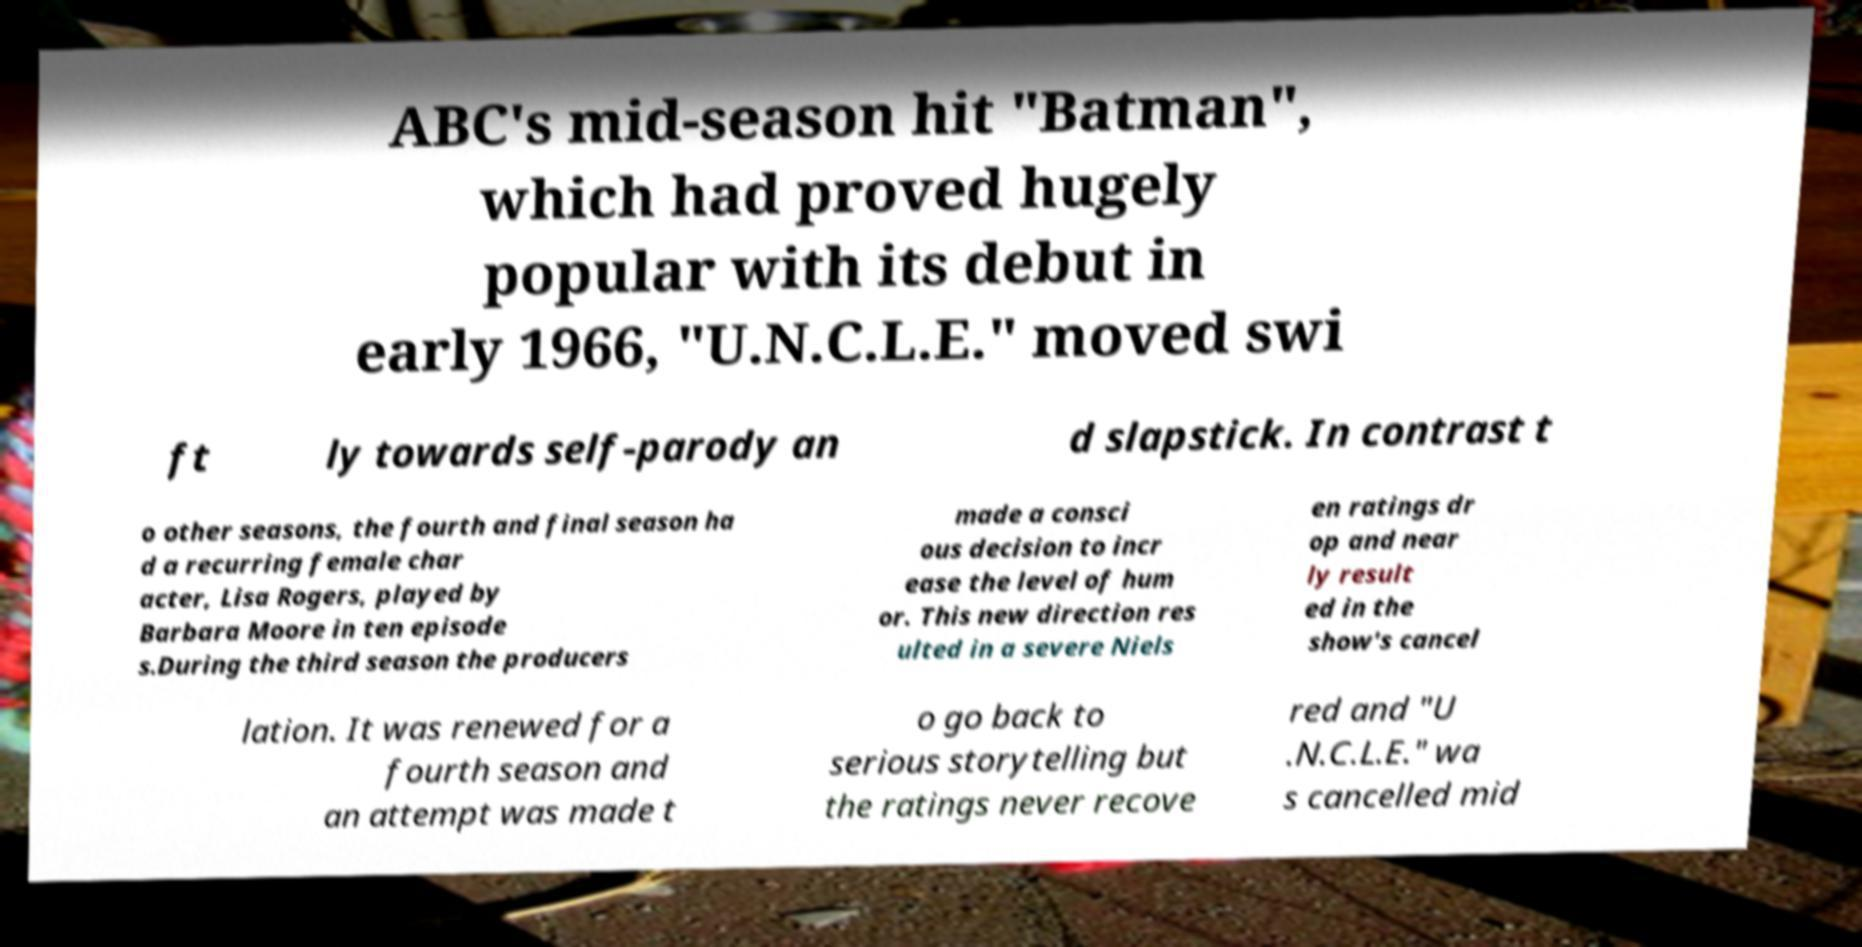Please identify and transcribe the text found in this image. ABC's mid-season hit "Batman", which had proved hugely popular with its debut in early 1966, "U.N.C.L.E." moved swi ft ly towards self-parody an d slapstick. In contrast t o other seasons, the fourth and final season ha d a recurring female char acter, Lisa Rogers, played by Barbara Moore in ten episode s.During the third season the producers made a consci ous decision to incr ease the level of hum or. This new direction res ulted in a severe Niels en ratings dr op and near ly result ed in the show's cancel lation. It was renewed for a fourth season and an attempt was made t o go back to serious storytelling but the ratings never recove red and "U .N.C.L.E." wa s cancelled mid 